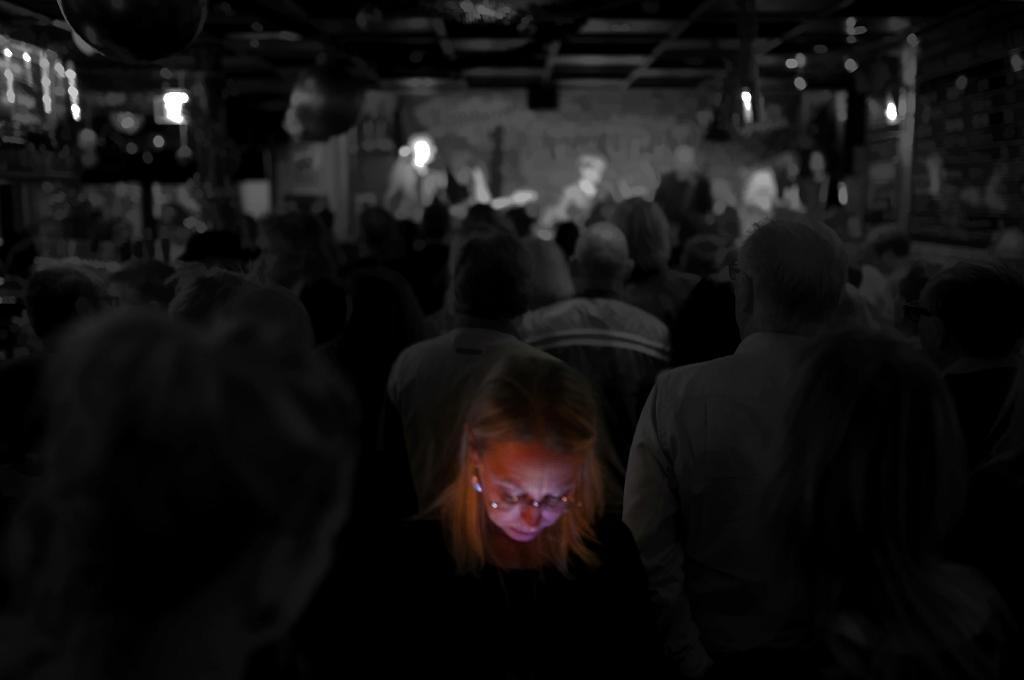Can you describe this image briefly? In this image we can see a person with a light on her face. Here we can see many people. The background of the image is slightly blurred. 